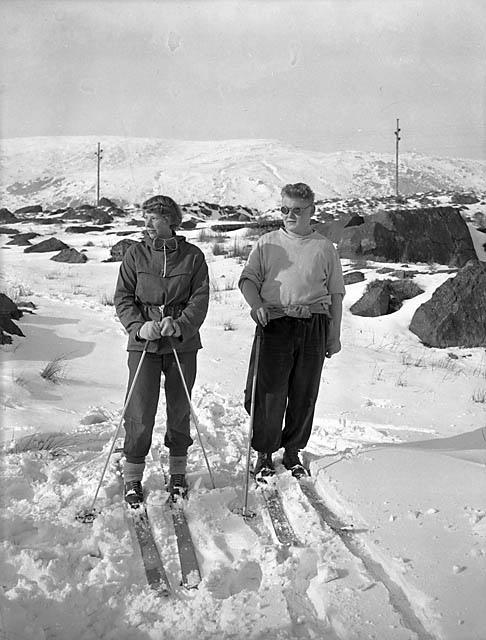Are these people in first grade?
Give a very brief answer. No. Is it summer?
Answer briefly. No. Is this the Alps?
Be succinct. No. 